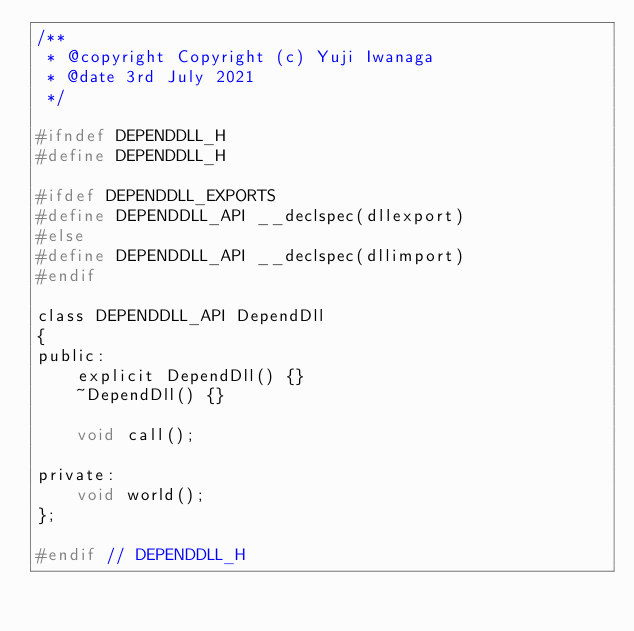<code> <loc_0><loc_0><loc_500><loc_500><_C_>/**
 * @copyright Copyright (c) Yuji Iwanaga
 * @date 3rd July 2021
 */

#ifndef DEPENDDLL_H
#define DEPENDDLL_H

#ifdef DEPENDDLL_EXPORTS
#define DEPENDDLL_API __declspec(dllexport)
#else
#define DEPENDDLL_API __declspec(dllimport)
#endif

class DEPENDDLL_API DependDll
{
public:
    explicit DependDll() {}
    ~DependDll() {}

    void call();

private:
    void world();
};

#endif // DEPENDDLL_H</code> 